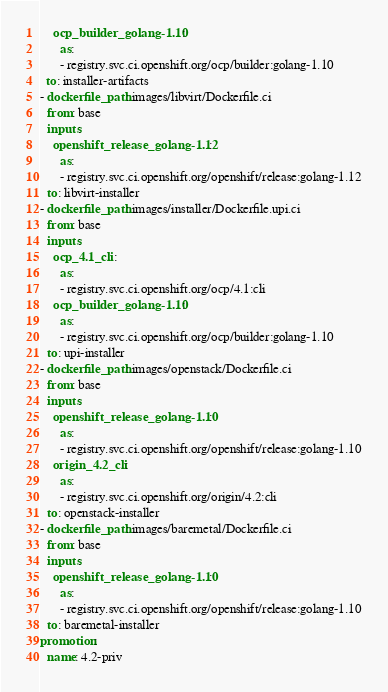Convert code to text. <code><loc_0><loc_0><loc_500><loc_500><_YAML_>    ocp_builder_golang-1.10:
      as:
      - registry.svc.ci.openshift.org/ocp/builder:golang-1.10
  to: installer-artifacts
- dockerfile_path: images/libvirt/Dockerfile.ci
  from: base
  inputs:
    openshift_release_golang-1.12:
      as:
      - registry.svc.ci.openshift.org/openshift/release:golang-1.12
  to: libvirt-installer
- dockerfile_path: images/installer/Dockerfile.upi.ci
  from: base
  inputs:
    ocp_4.1_cli:
      as:
      - registry.svc.ci.openshift.org/ocp/4.1:cli
    ocp_builder_golang-1.10:
      as:
      - registry.svc.ci.openshift.org/ocp/builder:golang-1.10
  to: upi-installer
- dockerfile_path: images/openstack/Dockerfile.ci
  from: base
  inputs:
    openshift_release_golang-1.10:
      as:
      - registry.svc.ci.openshift.org/openshift/release:golang-1.10
    origin_4.2_cli:
      as:
      - registry.svc.ci.openshift.org/origin/4.2:cli
  to: openstack-installer
- dockerfile_path: images/baremetal/Dockerfile.ci
  from: base
  inputs:
    openshift_release_golang-1.10:
      as:
      - registry.svc.ci.openshift.org/openshift/release:golang-1.10
  to: baremetal-installer
promotion:
  name: 4.2-priv</code> 